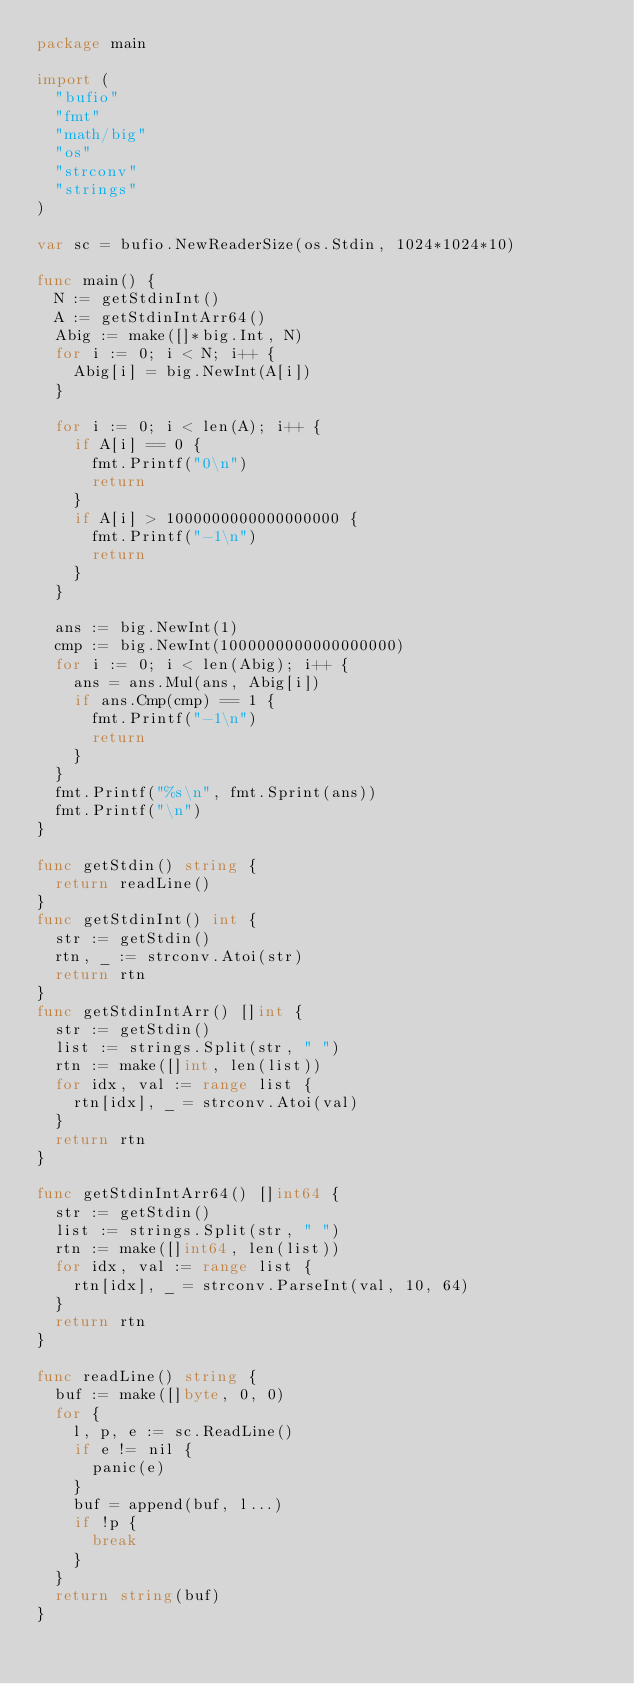<code> <loc_0><loc_0><loc_500><loc_500><_Go_>package main

import (
	"bufio"
	"fmt"
	"math/big"
	"os"
	"strconv"
	"strings"
)

var sc = bufio.NewReaderSize(os.Stdin, 1024*1024*10)

func main() {
	N := getStdinInt()
	A := getStdinIntArr64()
	Abig := make([]*big.Int, N)
	for i := 0; i < N; i++ {
		Abig[i] = big.NewInt(A[i])
	}

	for i := 0; i < len(A); i++ {
		if A[i] == 0 {
			fmt.Printf("0\n")
			return
		}
		if A[i] > 1000000000000000000 {
			fmt.Printf("-1\n")
			return
		}
	}

	ans := big.NewInt(1)
	cmp := big.NewInt(1000000000000000000)
	for i := 0; i < len(Abig); i++ {
		ans = ans.Mul(ans, Abig[i])
		if ans.Cmp(cmp) == 1 {
			fmt.Printf("-1\n")
			return
		}
	}
	fmt.Printf("%s\n", fmt.Sprint(ans))
	fmt.Printf("\n")
}

func getStdin() string {
	return readLine()
}
func getStdinInt() int {
	str := getStdin()
	rtn, _ := strconv.Atoi(str)
	return rtn
}
func getStdinIntArr() []int {
	str := getStdin()
	list := strings.Split(str, " ")
	rtn := make([]int, len(list))
	for idx, val := range list {
		rtn[idx], _ = strconv.Atoi(val)
	}
	return rtn
}

func getStdinIntArr64() []int64 {
	str := getStdin()
	list := strings.Split(str, " ")
	rtn := make([]int64, len(list))
	for idx, val := range list {
		rtn[idx], _ = strconv.ParseInt(val, 10, 64)
	}
	return rtn
}

func readLine() string {
	buf := make([]byte, 0, 0)
	for {
		l, p, e := sc.ReadLine()
		if e != nil {
			panic(e)
		}
		buf = append(buf, l...)
		if !p {
			break
		}
	}
	return string(buf)
}
</code> 